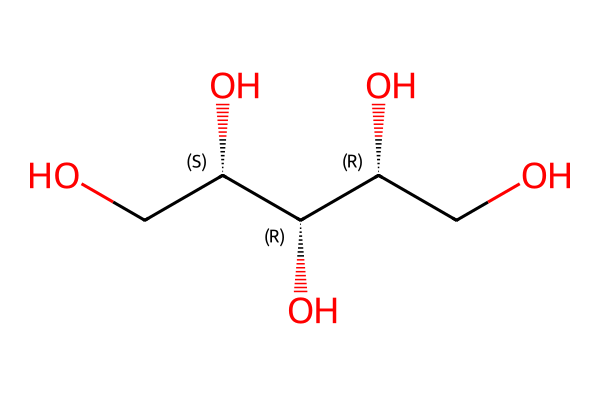What is the name of this chemical? The SMILES representation indicates the structure corresponds to xylitol, which is a sugar alcohol used as a sweetener.
Answer: xylitol How many carbon atoms are present in this compound? By analyzing the structure, we can count the carbon atoms. There are five carbon atoms in the structure of xylitol.
Answer: five Is this compound chiral? The presence of multiple stereocenters (indicated by @ symbols) in the SMILES string suggests that this compound has non-superimposable mirror images, confirming its chirality.
Answer: yes How many hydroxyl (OH) groups are present in xylitol? The structure shows that there are five distinct hydroxyl groups (indicated by the -OH attachments) attached to the carbon atoms in xylitol.
Answer: five What functional group is indicated in the xylitol structure? The presence of multiple -OH groups defines the primary functional group as alcohol, which characterizes xylitol.
Answer: alcohol Which atoms are directly involved in forming the chiral centers? The carbon atoms with attached hydroxyl groups are the chirality centers; specifically, the carbons that are marked with @ in the SMILES represent these chiral centers.
Answer: carbon atoms 